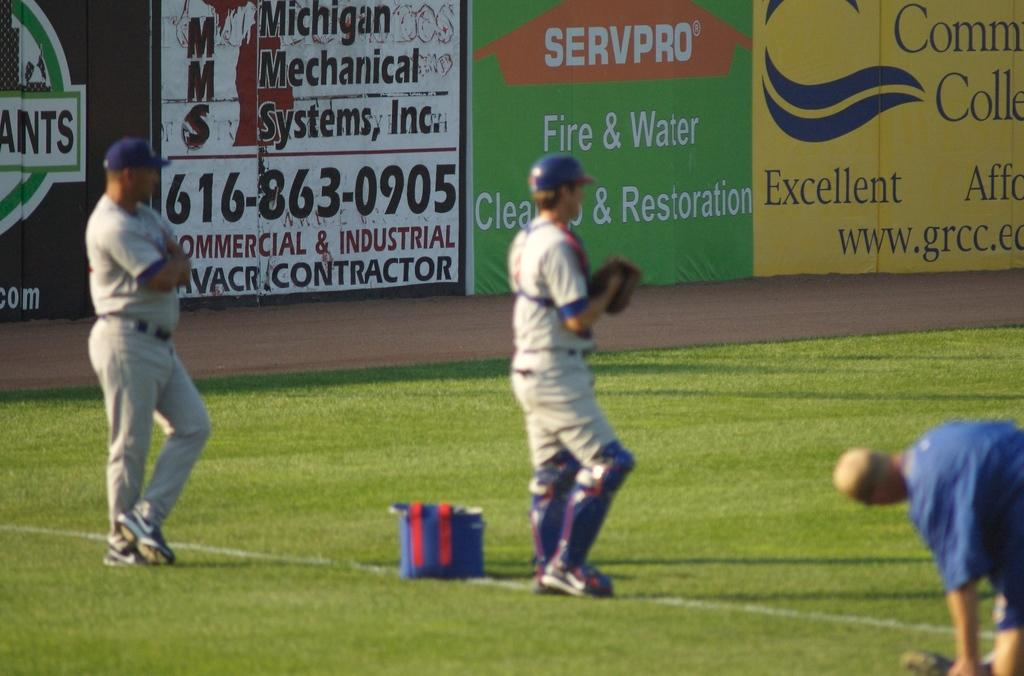<image>
Share a concise interpretation of the image provided. Players warming up on a baseball field with a sign for Servpro behind them. 